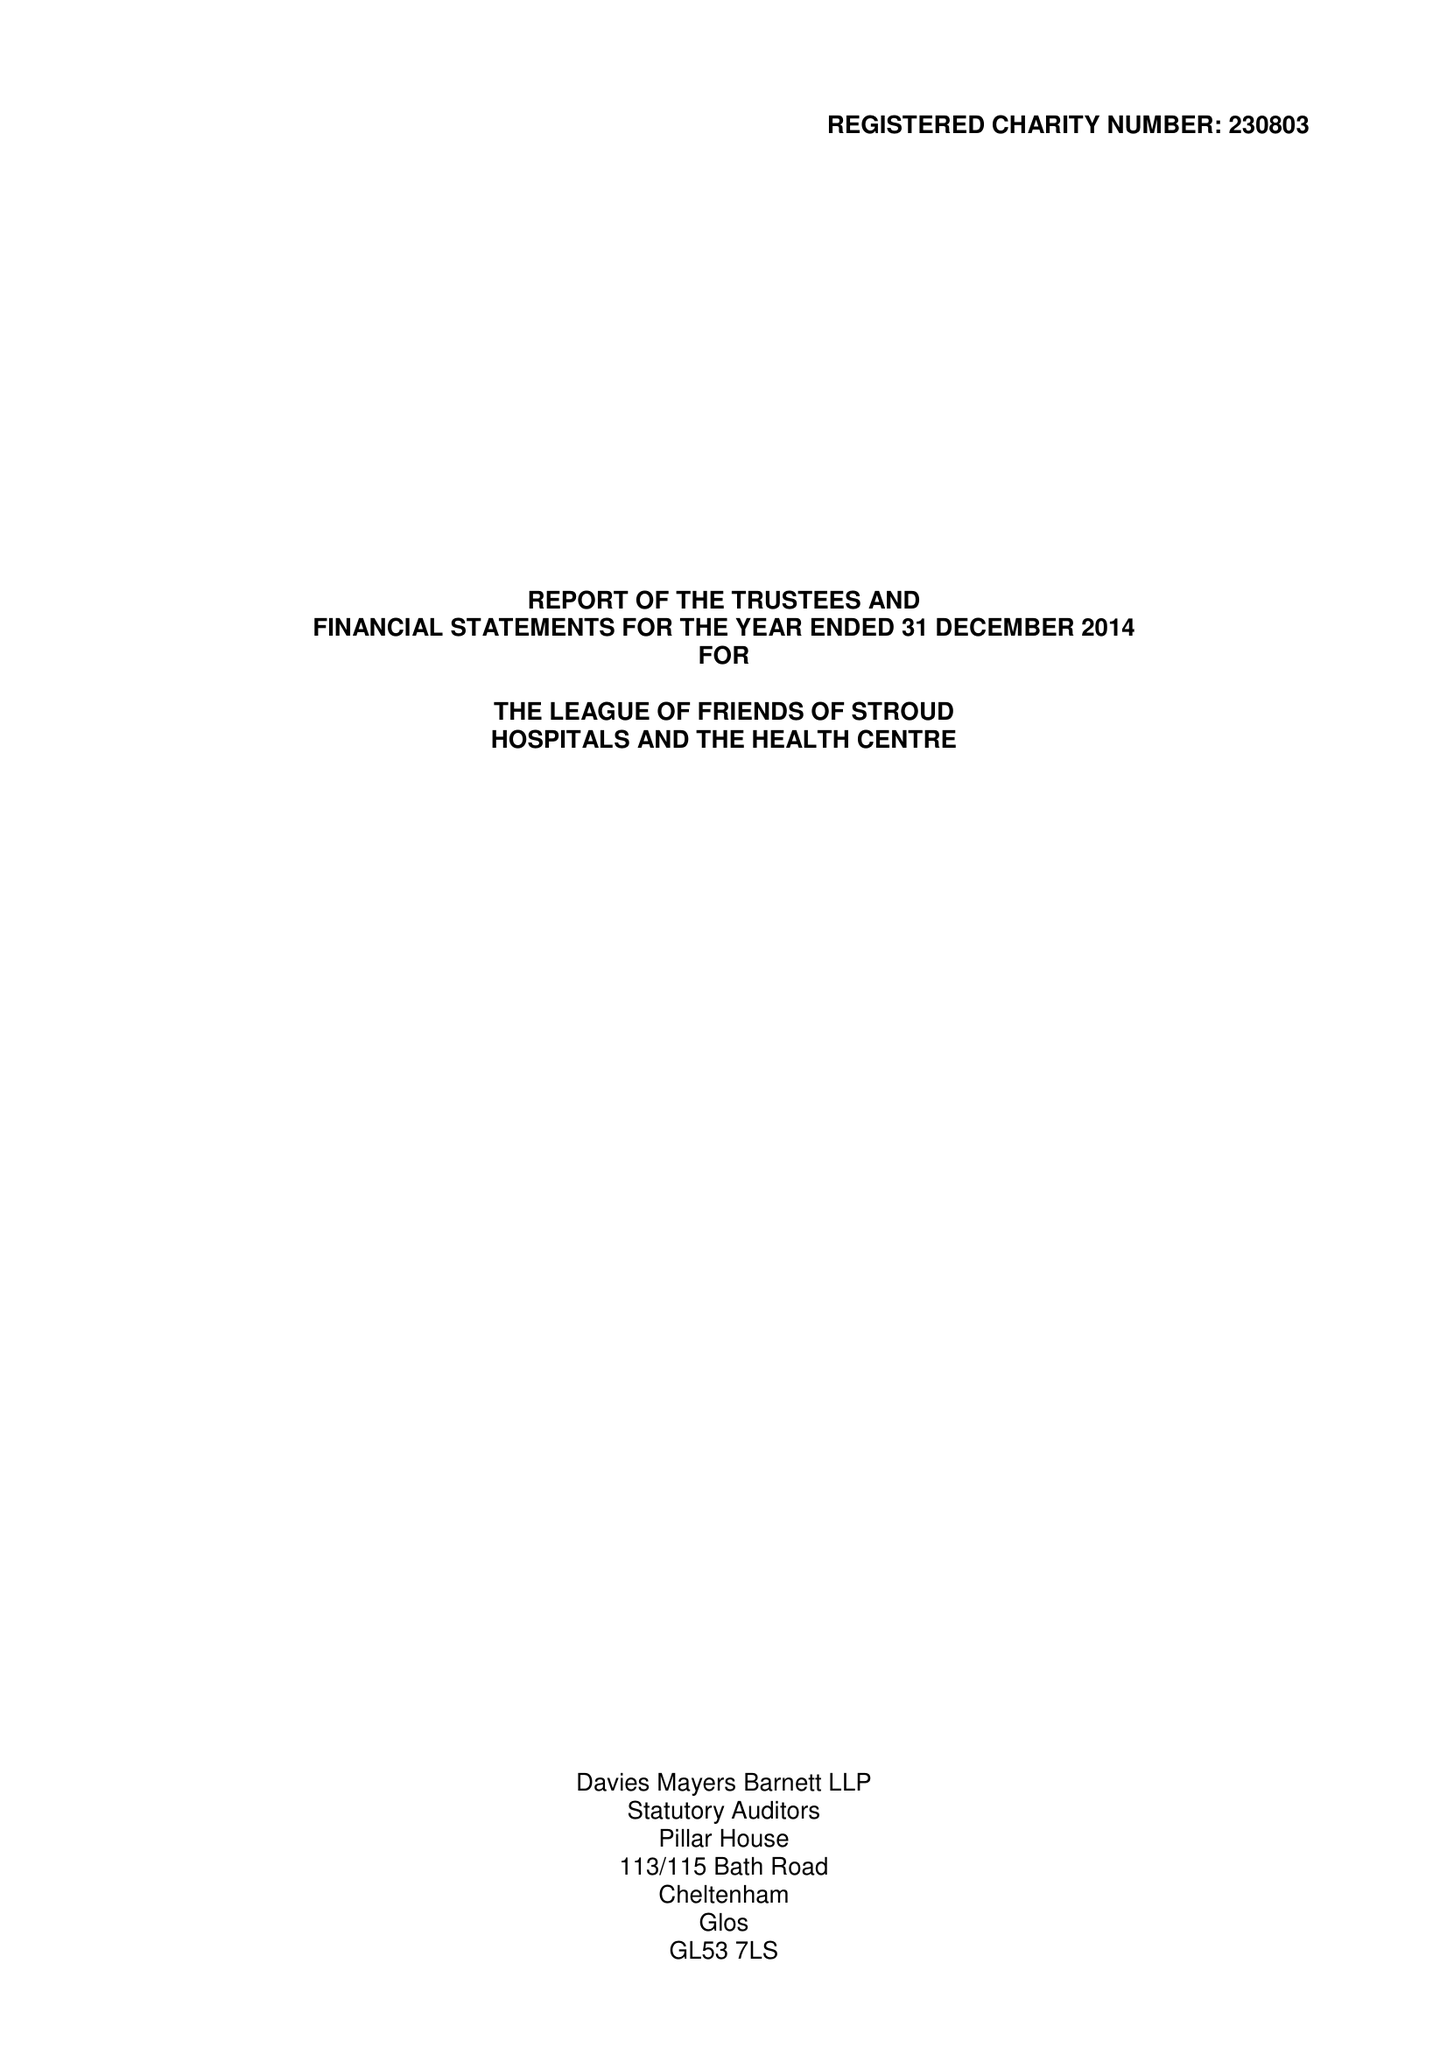What is the value for the charity_number?
Answer the question using a single word or phrase. 230803 